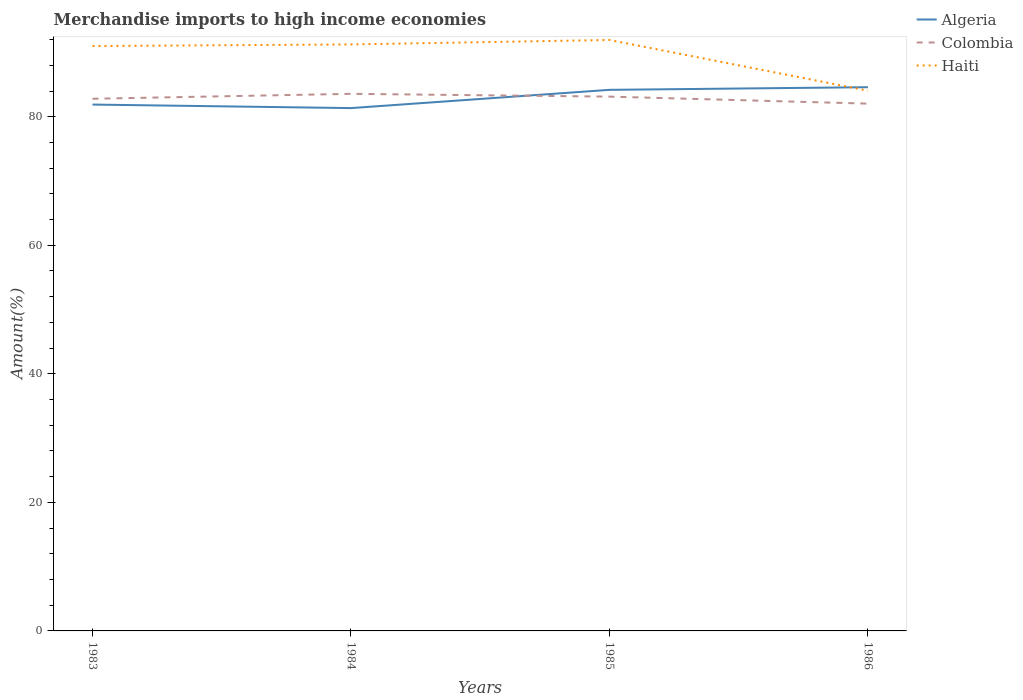Does the line corresponding to Haiti intersect with the line corresponding to Algeria?
Make the answer very short. Yes. Is the number of lines equal to the number of legend labels?
Provide a short and direct response. Yes. Across all years, what is the maximum percentage of amount earned from merchandise imports in Colombia?
Make the answer very short. 82.04. In which year was the percentage of amount earned from merchandise imports in Colombia maximum?
Make the answer very short. 1986. What is the total percentage of amount earned from merchandise imports in Haiti in the graph?
Your answer should be very brief. 6.95. What is the difference between the highest and the second highest percentage of amount earned from merchandise imports in Colombia?
Make the answer very short. 1.52. Is the percentage of amount earned from merchandise imports in Haiti strictly greater than the percentage of amount earned from merchandise imports in Colombia over the years?
Provide a succinct answer. No. How many lines are there?
Give a very brief answer. 3. What is the difference between two consecutive major ticks on the Y-axis?
Your answer should be compact. 20. Does the graph contain any zero values?
Make the answer very short. No. How many legend labels are there?
Offer a very short reply. 3. What is the title of the graph?
Provide a short and direct response. Merchandise imports to high income economies. Does "Liechtenstein" appear as one of the legend labels in the graph?
Provide a succinct answer. No. What is the label or title of the X-axis?
Offer a very short reply. Years. What is the label or title of the Y-axis?
Offer a terse response. Amount(%). What is the Amount(%) in Algeria in 1983?
Offer a terse response. 81.89. What is the Amount(%) in Colombia in 1983?
Your answer should be compact. 82.79. What is the Amount(%) of Haiti in 1983?
Your answer should be very brief. 90.99. What is the Amount(%) in Algeria in 1984?
Make the answer very short. 81.34. What is the Amount(%) in Colombia in 1984?
Ensure brevity in your answer.  83.56. What is the Amount(%) in Haiti in 1984?
Your response must be concise. 91.25. What is the Amount(%) of Algeria in 1985?
Provide a succinct answer. 84.18. What is the Amount(%) of Colombia in 1985?
Ensure brevity in your answer.  83.13. What is the Amount(%) in Haiti in 1985?
Provide a short and direct response. 91.94. What is the Amount(%) in Algeria in 1986?
Your answer should be very brief. 84.59. What is the Amount(%) of Colombia in 1986?
Ensure brevity in your answer.  82.04. What is the Amount(%) in Haiti in 1986?
Provide a succinct answer. 84.05. Across all years, what is the maximum Amount(%) of Algeria?
Your answer should be very brief. 84.59. Across all years, what is the maximum Amount(%) of Colombia?
Ensure brevity in your answer.  83.56. Across all years, what is the maximum Amount(%) of Haiti?
Provide a short and direct response. 91.94. Across all years, what is the minimum Amount(%) of Algeria?
Provide a short and direct response. 81.34. Across all years, what is the minimum Amount(%) in Colombia?
Provide a short and direct response. 82.04. Across all years, what is the minimum Amount(%) of Haiti?
Offer a very short reply. 84.05. What is the total Amount(%) of Algeria in the graph?
Provide a succinct answer. 332. What is the total Amount(%) in Colombia in the graph?
Make the answer very short. 331.52. What is the total Amount(%) of Haiti in the graph?
Provide a short and direct response. 358.23. What is the difference between the Amount(%) in Algeria in 1983 and that in 1984?
Ensure brevity in your answer.  0.55. What is the difference between the Amount(%) in Colombia in 1983 and that in 1984?
Your response must be concise. -0.77. What is the difference between the Amount(%) of Haiti in 1983 and that in 1984?
Your answer should be compact. -0.25. What is the difference between the Amount(%) of Algeria in 1983 and that in 1985?
Provide a succinct answer. -2.29. What is the difference between the Amount(%) in Colombia in 1983 and that in 1985?
Keep it short and to the point. -0.33. What is the difference between the Amount(%) of Haiti in 1983 and that in 1985?
Ensure brevity in your answer.  -0.94. What is the difference between the Amount(%) of Algeria in 1983 and that in 1986?
Provide a succinct answer. -2.7. What is the difference between the Amount(%) in Colombia in 1983 and that in 1986?
Provide a succinct answer. 0.76. What is the difference between the Amount(%) of Haiti in 1983 and that in 1986?
Your answer should be compact. 6.95. What is the difference between the Amount(%) in Algeria in 1984 and that in 1985?
Keep it short and to the point. -2.84. What is the difference between the Amount(%) in Colombia in 1984 and that in 1985?
Keep it short and to the point. 0.43. What is the difference between the Amount(%) of Haiti in 1984 and that in 1985?
Your response must be concise. -0.69. What is the difference between the Amount(%) of Algeria in 1984 and that in 1986?
Ensure brevity in your answer.  -3.25. What is the difference between the Amount(%) of Colombia in 1984 and that in 1986?
Your answer should be compact. 1.52. What is the difference between the Amount(%) in Haiti in 1984 and that in 1986?
Ensure brevity in your answer.  7.2. What is the difference between the Amount(%) of Algeria in 1985 and that in 1986?
Ensure brevity in your answer.  -0.41. What is the difference between the Amount(%) of Colombia in 1985 and that in 1986?
Your answer should be very brief. 1.09. What is the difference between the Amount(%) of Haiti in 1985 and that in 1986?
Your answer should be very brief. 7.89. What is the difference between the Amount(%) in Algeria in 1983 and the Amount(%) in Colombia in 1984?
Offer a very short reply. -1.67. What is the difference between the Amount(%) of Algeria in 1983 and the Amount(%) of Haiti in 1984?
Offer a terse response. -9.36. What is the difference between the Amount(%) of Colombia in 1983 and the Amount(%) of Haiti in 1984?
Provide a succinct answer. -8.45. What is the difference between the Amount(%) in Algeria in 1983 and the Amount(%) in Colombia in 1985?
Ensure brevity in your answer.  -1.24. What is the difference between the Amount(%) of Algeria in 1983 and the Amount(%) of Haiti in 1985?
Provide a succinct answer. -10.05. What is the difference between the Amount(%) of Colombia in 1983 and the Amount(%) of Haiti in 1985?
Offer a very short reply. -9.14. What is the difference between the Amount(%) in Algeria in 1983 and the Amount(%) in Colombia in 1986?
Offer a terse response. -0.14. What is the difference between the Amount(%) of Algeria in 1983 and the Amount(%) of Haiti in 1986?
Offer a very short reply. -2.16. What is the difference between the Amount(%) in Colombia in 1983 and the Amount(%) in Haiti in 1986?
Make the answer very short. -1.25. What is the difference between the Amount(%) of Algeria in 1984 and the Amount(%) of Colombia in 1985?
Ensure brevity in your answer.  -1.79. What is the difference between the Amount(%) of Algeria in 1984 and the Amount(%) of Haiti in 1985?
Your response must be concise. -10.6. What is the difference between the Amount(%) in Colombia in 1984 and the Amount(%) in Haiti in 1985?
Give a very brief answer. -8.38. What is the difference between the Amount(%) in Algeria in 1984 and the Amount(%) in Colombia in 1986?
Keep it short and to the point. -0.69. What is the difference between the Amount(%) of Algeria in 1984 and the Amount(%) of Haiti in 1986?
Your answer should be compact. -2.71. What is the difference between the Amount(%) of Colombia in 1984 and the Amount(%) of Haiti in 1986?
Provide a short and direct response. -0.49. What is the difference between the Amount(%) of Algeria in 1985 and the Amount(%) of Colombia in 1986?
Your answer should be very brief. 2.14. What is the difference between the Amount(%) in Algeria in 1985 and the Amount(%) in Haiti in 1986?
Your answer should be very brief. 0.13. What is the difference between the Amount(%) in Colombia in 1985 and the Amount(%) in Haiti in 1986?
Offer a terse response. -0.92. What is the average Amount(%) of Algeria per year?
Offer a terse response. 83. What is the average Amount(%) in Colombia per year?
Your answer should be very brief. 82.88. What is the average Amount(%) of Haiti per year?
Give a very brief answer. 89.56. In the year 1983, what is the difference between the Amount(%) in Algeria and Amount(%) in Colombia?
Your response must be concise. -0.9. In the year 1983, what is the difference between the Amount(%) in Algeria and Amount(%) in Haiti?
Give a very brief answer. -9.1. In the year 1983, what is the difference between the Amount(%) in Colombia and Amount(%) in Haiti?
Your answer should be very brief. -8.2. In the year 1984, what is the difference between the Amount(%) in Algeria and Amount(%) in Colombia?
Offer a terse response. -2.22. In the year 1984, what is the difference between the Amount(%) of Algeria and Amount(%) of Haiti?
Keep it short and to the point. -9.9. In the year 1984, what is the difference between the Amount(%) in Colombia and Amount(%) in Haiti?
Your answer should be very brief. -7.69. In the year 1985, what is the difference between the Amount(%) of Algeria and Amount(%) of Colombia?
Offer a very short reply. 1.05. In the year 1985, what is the difference between the Amount(%) in Algeria and Amount(%) in Haiti?
Offer a terse response. -7.76. In the year 1985, what is the difference between the Amount(%) in Colombia and Amount(%) in Haiti?
Offer a very short reply. -8.81. In the year 1986, what is the difference between the Amount(%) of Algeria and Amount(%) of Colombia?
Give a very brief answer. 2.56. In the year 1986, what is the difference between the Amount(%) of Algeria and Amount(%) of Haiti?
Provide a short and direct response. 0.54. In the year 1986, what is the difference between the Amount(%) in Colombia and Amount(%) in Haiti?
Ensure brevity in your answer.  -2.01. What is the ratio of the Amount(%) of Algeria in 1983 to that in 1984?
Keep it short and to the point. 1.01. What is the ratio of the Amount(%) of Colombia in 1983 to that in 1984?
Give a very brief answer. 0.99. What is the ratio of the Amount(%) in Algeria in 1983 to that in 1985?
Your answer should be very brief. 0.97. What is the ratio of the Amount(%) of Haiti in 1983 to that in 1985?
Offer a terse response. 0.99. What is the ratio of the Amount(%) in Algeria in 1983 to that in 1986?
Keep it short and to the point. 0.97. What is the ratio of the Amount(%) of Colombia in 1983 to that in 1986?
Make the answer very short. 1.01. What is the ratio of the Amount(%) in Haiti in 1983 to that in 1986?
Keep it short and to the point. 1.08. What is the ratio of the Amount(%) in Algeria in 1984 to that in 1985?
Offer a very short reply. 0.97. What is the ratio of the Amount(%) of Colombia in 1984 to that in 1985?
Offer a terse response. 1.01. What is the ratio of the Amount(%) of Algeria in 1984 to that in 1986?
Your answer should be very brief. 0.96. What is the ratio of the Amount(%) in Colombia in 1984 to that in 1986?
Give a very brief answer. 1.02. What is the ratio of the Amount(%) of Haiti in 1984 to that in 1986?
Provide a succinct answer. 1.09. What is the ratio of the Amount(%) in Algeria in 1985 to that in 1986?
Ensure brevity in your answer.  1. What is the ratio of the Amount(%) in Colombia in 1985 to that in 1986?
Offer a terse response. 1.01. What is the ratio of the Amount(%) of Haiti in 1985 to that in 1986?
Provide a succinct answer. 1.09. What is the difference between the highest and the second highest Amount(%) in Algeria?
Your answer should be compact. 0.41. What is the difference between the highest and the second highest Amount(%) of Colombia?
Your response must be concise. 0.43. What is the difference between the highest and the second highest Amount(%) of Haiti?
Give a very brief answer. 0.69. What is the difference between the highest and the lowest Amount(%) of Algeria?
Your answer should be very brief. 3.25. What is the difference between the highest and the lowest Amount(%) in Colombia?
Your answer should be very brief. 1.52. What is the difference between the highest and the lowest Amount(%) in Haiti?
Your answer should be compact. 7.89. 